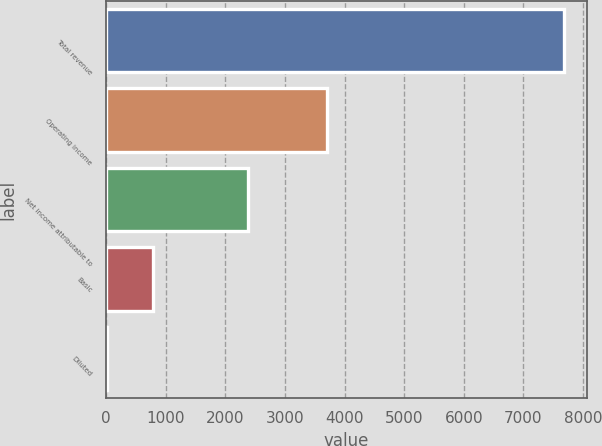<chart> <loc_0><loc_0><loc_500><loc_500><bar_chart><fcel>Total revenue<fcel>Operating income<fcel>Net income attributable to<fcel>Basic<fcel>Diluted<nl><fcel>7676<fcel>3712<fcel>2382<fcel>778.61<fcel>12.23<nl></chart> 